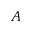<formula> <loc_0><loc_0><loc_500><loc_500>A</formula> 